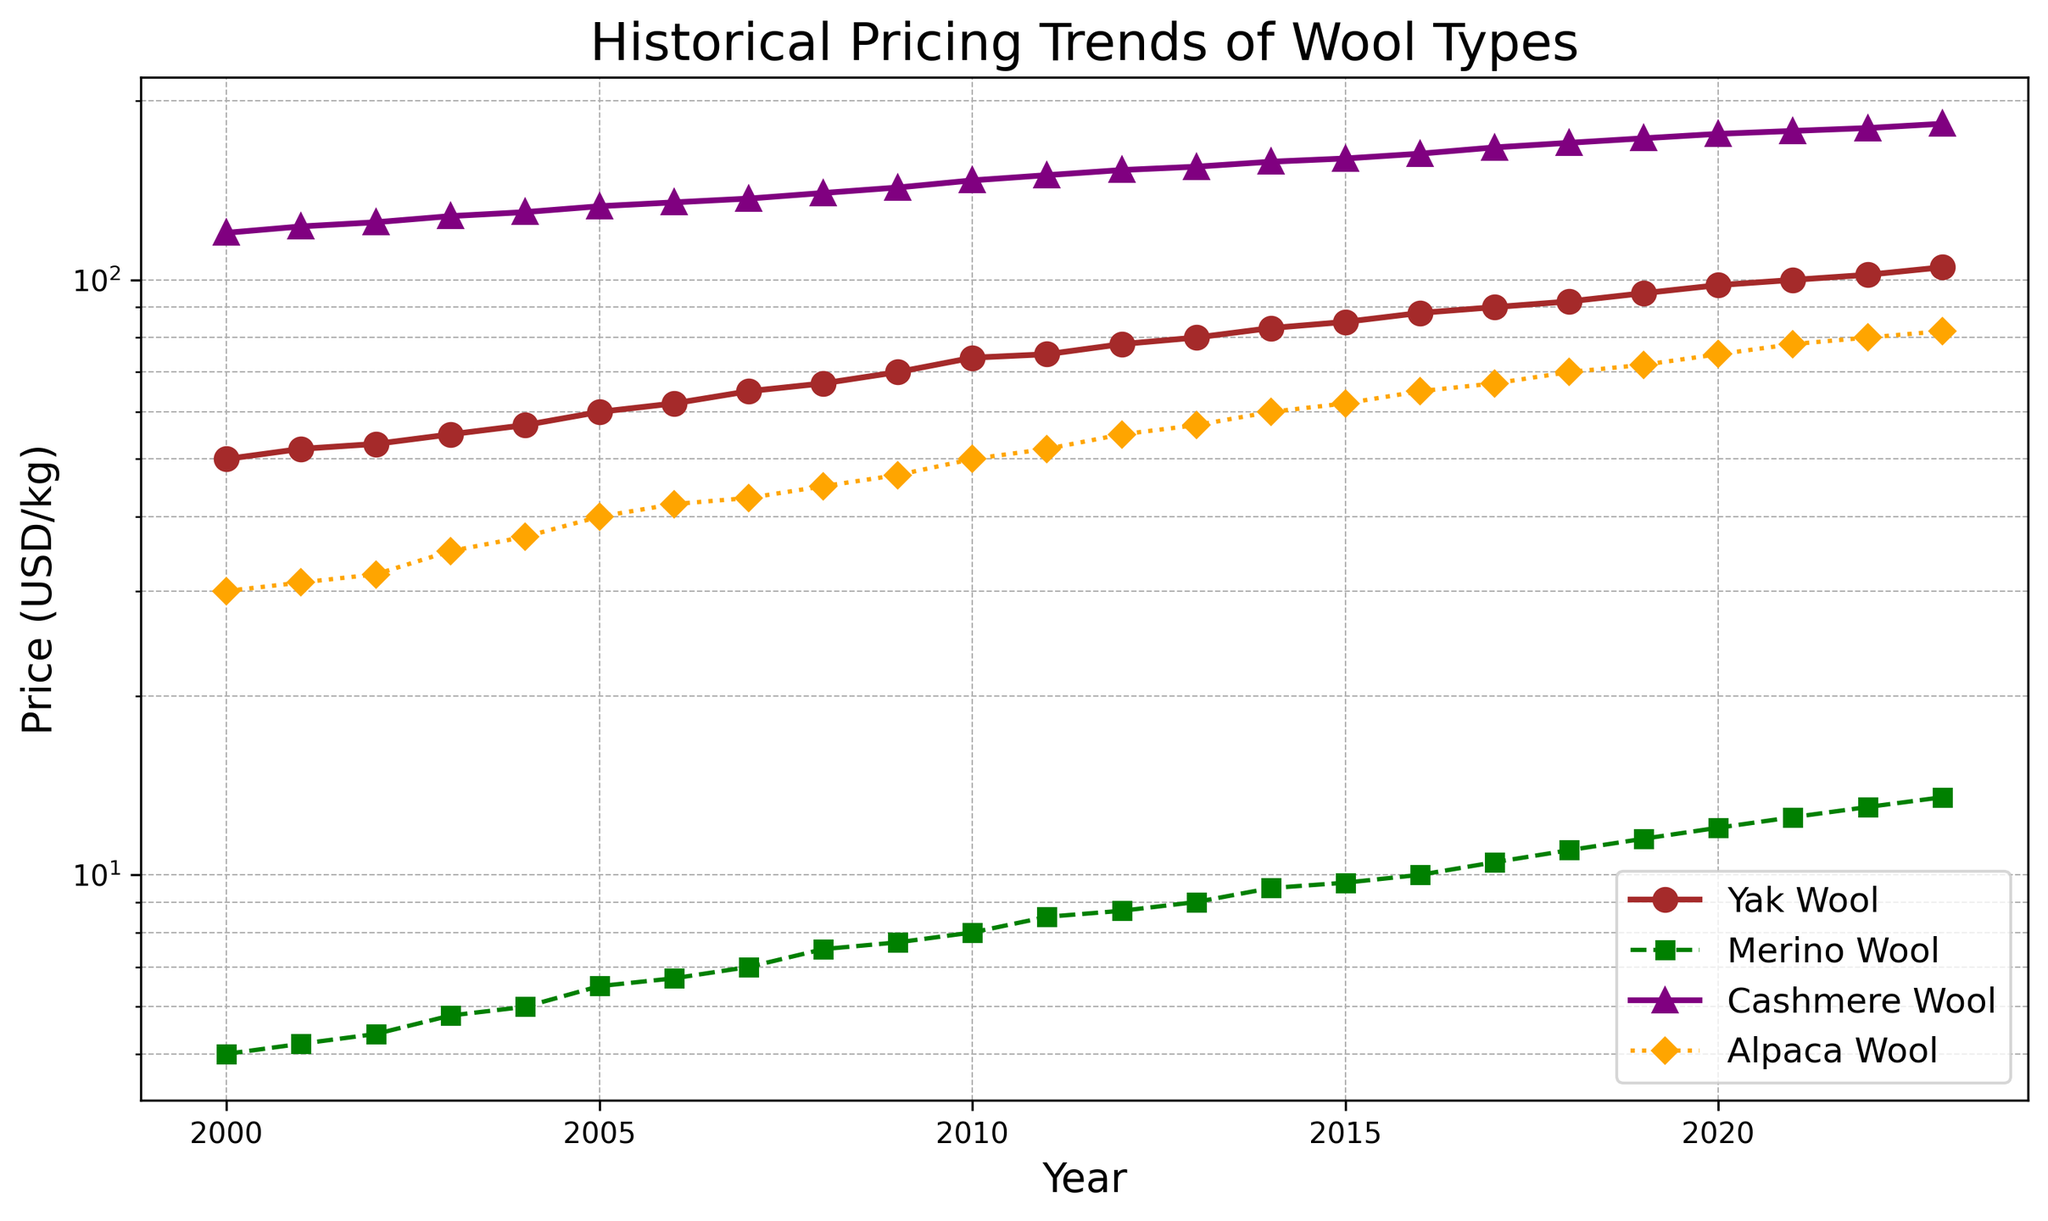Which wool type shows the highest price in 2000? To find the highest price, look at the y-axis values for different wool types in the year 2000 and compare them. Yak Wool (50), Merino Wool (5), Cashmere Wool (120), Alpaca Wool (30). The highest price is 120 USD/kg for Cashmere Wool.
Answer: Cashmere Wool How has the price of Yak wool changed from 2000 to 2023? Locate the Yak Wool price points on the y-axis for the years 2000 and 2023. The price increased from 50 USD/kg in 2000 to 105 USD/kg in 2023. Calculate the difference: 105 - 50 = 55 USD/kg.
Answer: Increased by 55 USD/kg Which wool type had the most consistent pricing trend from 2000 to 2023? Observe the slopes of the lines for each wool type. The line with minimal fluctuations indicates the most consistent trend. Merino Wool has the most consistent (steady) upward trend with a relatively smooth and slight increase as compared to others.
Answer: Merino Wool In which year did Alpaca wool's price surpass 50 USD/kg? Check Alpaca Wool's price along the y-axis year by year. The price surpasses 50 USD/kg in the year 2010.
Answer: 2010 Compare the price trends of Merino Wool and Cashmere Wool. Which type had a steeper increase over the years? Look at the slopes of the trend lines for Merino Wool and Cashmere Wool. Cashmere Wool shows a steeper slope, indicating a more significant price increase over the years compared to Merino Wool.
Answer: Cashmere Wool Which wool type had the lowest starting price in 2000 and what was it? Compare the prices of all wool types in the year 2000. Merino Wool had the lowest price at 5 USD/kg.
Answer: Merino Wool On average, by how much did the price of Alpaca Wool increase each year from 2000 to 2023? Calculate the total price increase for Alpaca Wool from 2000 (30 USD/kg) to 2023 (82 USD/kg): 82 - 30 = 52 USD/kg over 23 years. Average annual increase = 52 / 23 ≈ 2.26 USD/kg per year.
Answer: ≈ 2.26 USD/kg per year Which wool type experienced the largest percentage increase in price from 2000 to 2023? Calculate the percentage increase for each wool type: Yak Wool (105-50)/50*100 = 110%, Merino Wool (13.5-5)/5*100 = 170%, Cashmere Wool (183-120)/120*100 = 52.5%, Alpaca Wool (82-30)/30*100 = 173.3%. The highest percentage increase is for Alpaca Wool.
Answer: Alpaca Wool Between 2010 and 2015, which wool type had the fastest price growth rate? Measure the price increase for each wool type between 2010 and 2015: Yak Wool (85-74 = 11), Merino Wool (9.7-8 = 1.7), Cashmere Wool (160-147 = 13), Alpaca Wool (62-50 = 12). Cashmere Wool had the highest increase of 13 USD/kg.
Answer: Cashmere Wool 